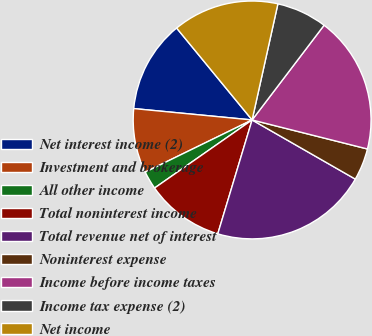Convert chart. <chart><loc_0><loc_0><loc_500><loc_500><pie_chart><fcel>Net interest income (2)<fcel>Investment and brokerage<fcel>All other income<fcel>Total noninterest income<fcel>Total revenue net of interest<fcel>Noninterest expense<fcel>Income before income taxes<fcel>Income tax expense (2)<fcel>Net income<nl><fcel>12.53%<fcel>8.75%<fcel>2.47%<fcel>10.64%<fcel>21.37%<fcel>4.36%<fcel>18.58%<fcel>6.86%<fcel>14.42%<nl></chart> 